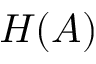Convert formula to latex. <formula><loc_0><loc_0><loc_500><loc_500>H ( A )</formula> 